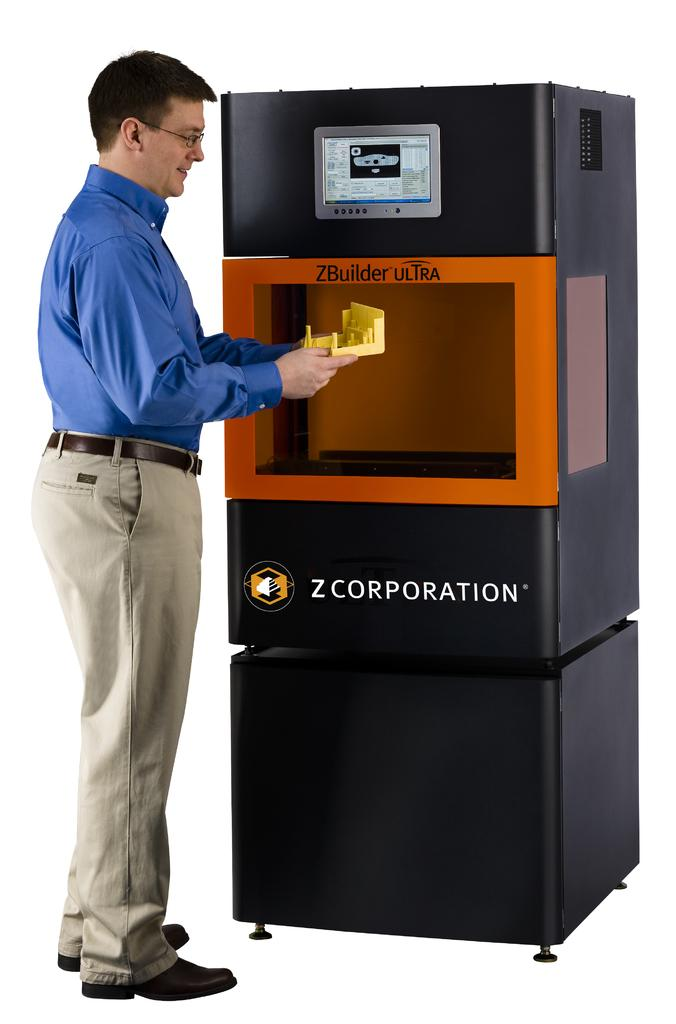<image>
Summarize the visual content of the image. The machine is from the company Z Corporation 